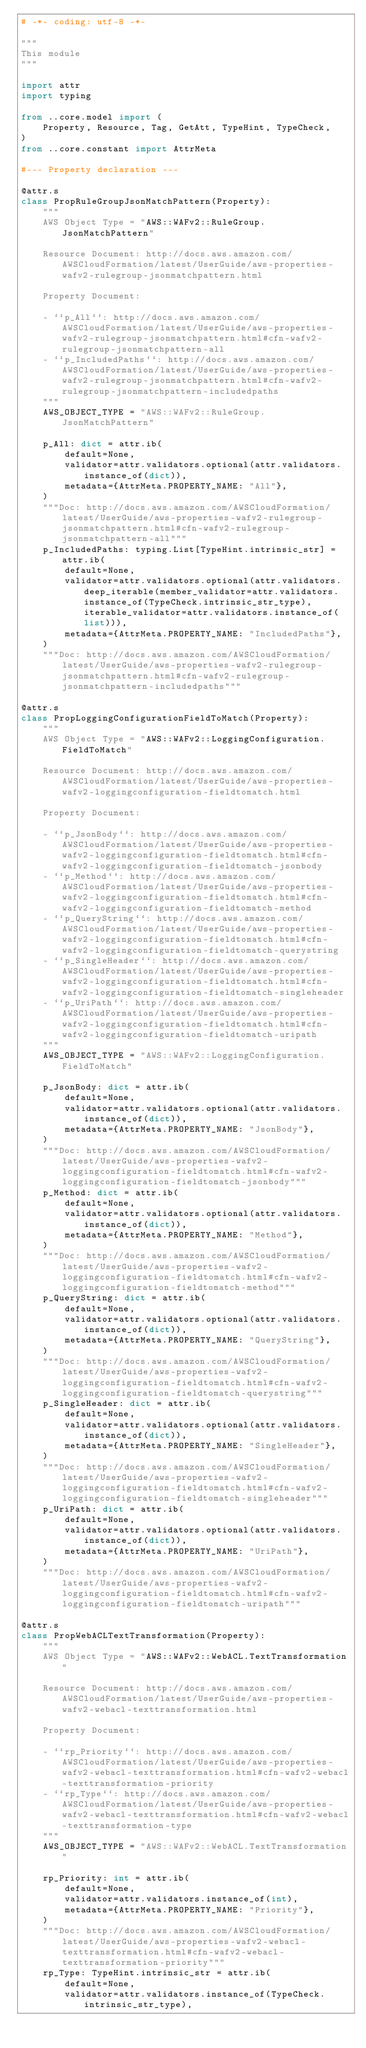Convert code to text. <code><loc_0><loc_0><loc_500><loc_500><_Python_># -*- coding: utf-8 -*-

"""
This module
"""

import attr
import typing

from ..core.model import (
    Property, Resource, Tag, GetAtt, TypeHint, TypeCheck,
)
from ..core.constant import AttrMeta

#--- Property declaration ---

@attr.s
class PropRuleGroupJsonMatchPattern(Property):
    """
    AWS Object Type = "AWS::WAFv2::RuleGroup.JsonMatchPattern"

    Resource Document: http://docs.aws.amazon.com/AWSCloudFormation/latest/UserGuide/aws-properties-wafv2-rulegroup-jsonmatchpattern.html

    Property Document:
    
    - ``p_All``: http://docs.aws.amazon.com/AWSCloudFormation/latest/UserGuide/aws-properties-wafv2-rulegroup-jsonmatchpattern.html#cfn-wafv2-rulegroup-jsonmatchpattern-all
    - ``p_IncludedPaths``: http://docs.aws.amazon.com/AWSCloudFormation/latest/UserGuide/aws-properties-wafv2-rulegroup-jsonmatchpattern.html#cfn-wafv2-rulegroup-jsonmatchpattern-includedpaths
    """
    AWS_OBJECT_TYPE = "AWS::WAFv2::RuleGroup.JsonMatchPattern"
    
    p_All: dict = attr.ib(
        default=None,
        validator=attr.validators.optional(attr.validators.instance_of(dict)),
        metadata={AttrMeta.PROPERTY_NAME: "All"},
    )
    """Doc: http://docs.aws.amazon.com/AWSCloudFormation/latest/UserGuide/aws-properties-wafv2-rulegroup-jsonmatchpattern.html#cfn-wafv2-rulegroup-jsonmatchpattern-all"""
    p_IncludedPaths: typing.List[TypeHint.intrinsic_str] = attr.ib(
        default=None,
        validator=attr.validators.optional(attr.validators.deep_iterable(member_validator=attr.validators.instance_of(TypeCheck.intrinsic_str_type), iterable_validator=attr.validators.instance_of(list))),
        metadata={AttrMeta.PROPERTY_NAME: "IncludedPaths"},
    )
    """Doc: http://docs.aws.amazon.com/AWSCloudFormation/latest/UserGuide/aws-properties-wafv2-rulegroup-jsonmatchpattern.html#cfn-wafv2-rulegroup-jsonmatchpattern-includedpaths"""

@attr.s
class PropLoggingConfigurationFieldToMatch(Property):
    """
    AWS Object Type = "AWS::WAFv2::LoggingConfiguration.FieldToMatch"

    Resource Document: http://docs.aws.amazon.com/AWSCloudFormation/latest/UserGuide/aws-properties-wafv2-loggingconfiguration-fieldtomatch.html

    Property Document:
    
    - ``p_JsonBody``: http://docs.aws.amazon.com/AWSCloudFormation/latest/UserGuide/aws-properties-wafv2-loggingconfiguration-fieldtomatch.html#cfn-wafv2-loggingconfiguration-fieldtomatch-jsonbody
    - ``p_Method``: http://docs.aws.amazon.com/AWSCloudFormation/latest/UserGuide/aws-properties-wafv2-loggingconfiguration-fieldtomatch.html#cfn-wafv2-loggingconfiguration-fieldtomatch-method
    - ``p_QueryString``: http://docs.aws.amazon.com/AWSCloudFormation/latest/UserGuide/aws-properties-wafv2-loggingconfiguration-fieldtomatch.html#cfn-wafv2-loggingconfiguration-fieldtomatch-querystring
    - ``p_SingleHeader``: http://docs.aws.amazon.com/AWSCloudFormation/latest/UserGuide/aws-properties-wafv2-loggingconfiguration-fieldtomatch.html#cfn-wafv2-loggingconfiguration-fieldtomatch-singleheader
    - ``p_UriPath``: http://docs.aws.amazon.com/AWSCloudFormation/latest/UserGuide/aws-properties-wafv2-loggingconfiguration-fieldtomatch.html#cfn-wafv2-loggingconfiguration-fieldtomatch-uripath
    """
    AWS_OBJECT_TYPE = "AWS::WAFv2::LoggingConfiguration.FieldToMatch"
    
    p_JsonBody: dict = attr.ib(
        default=None,
        validator=attr.validators.optional(attr.validators.instance_of(dict)),
        metadata={AttrMeta.PROPERTY_NAME: "JsonBody"},
    )
    """Doc: http://docs.aws.amazon.com/AWSCloudFormation/latest/UserGuide/aws-properties-wafv2-loggingconfiguration-fieldtomatch.html#cfn-wafv2-loggingconfiguration-fieldtomatch-jsonbody"""
    p_Method: dict = attr.ib(
        default=None,
        validator=attr.validators.optional(attr.validators.instance_of(dict)),
        metadata={AttrMeta.PROPERTY_NAME: "Method"},
    )
    """Doc: http://docs.aws.amazon.com/AWSCloudFormation/latest/UserGuide/aws-properties-wafv2-loggingconfiguration-fieldtomatch.html#cfn-wafv2-loggingconfiguration-fieldtomatch-method"""
    p_QueryString: dict = attr.ib(
        default=None,
        validator=attr.validators.optional(attr.validators.instance_of(dict)),
        metadata={AttrMeta.PROPERTY_NAME: "QueryString"},
    )
    """Doc: http://docs.aws.amazon.com/AWSCloudFormation/latest/UserGuide/aws-properties-wafv2-loggingconfiguration-fieldtomatch.html#cfn-wafv2-loggingconfiguration-fieldtomatch-querystring"""
    p_SingleHeader: dict = attr.ib(
        default=None,
        validator=attr.validators.optional(attr.validators.instance_of(dict)),
        metadata={AttrMeta.PROPERTY_NAME: "SingleHeader"},
    )
    """Doc: http://docs.aws.amazon.com/AWSCloudFormation/latest/UserGuide/aws-properties-wafv2-loggingconfiguration-fieldtomatch.html#cfn-wafv2-loggingconfiguration-fieldtomatch-singleheader"""
    p_UriPath: dict = attr.ib(
        default=None,
        validator=attr.validators.optional(attr.validators.instance_of(dict)),
        metadata={AttrMeta.PROPERTY_NAME: "UriPath"},
    )
    """Doc: http://docs.aws.amazon.com/AWSCloudFormation/latest/UserGuide/aws-properties-wafv2-loggingconfiguration-fieldtomatch.html#cfn-wafv2-loggingconfiguration-fieldtomatch-uripath"""

@attr.s
class PropWebACLTextTransformation(Property):
    """
    AWS Object Type = "AWS::WAFv2::WebACL.TextTransformation"

    Resource Document: http://docs.aws.amazon.com/AWSCloudFormation/latest/UserGuide/aws-properties-wafv2-webacl-texttransformation.html

    Property Document:
    
    - ``rp_Priority``: http://docs.aws.amazon.com/AWSCloudFormation/latest/UserGuide/aws-properties-wafv2-webacl-texttransformation.html#cfn-wafv2-webacl-texttransformation-priority
    - ``rp_Type``: http://docs.aws.amazon.com/AWSCloudFormation/latest/UserGuide/aws-properties-wafv2-webacl-texttransformation.html#cfn-wafv2-webacl-texttransformation-type
    """
    AWS_OBJECT_TYPE = "AWS::WAFv2::WebACL.TextTransformation"
    
    rp_Priority: int = attr.ib(
        default=None,
        validator=attr.validators.instance_of(int),
        metadata={AttrMeta.PROPERTY_NAME: "Priority"},
    )
    """Doc: http://docs.aws.amazon.com/AWSCloudFormation/latest/UserGuide/aws-properties-wafv2-webacl-texttransformation.html#cfn-wafv2-webacl-texttransformation-priority"""
    rp_Type: TypeHint.intrinsic_str = attr.ib(
        default=None,
        validator=attr.validators.instance_of(TypeCheck.intrinsic_str_type),</code> 